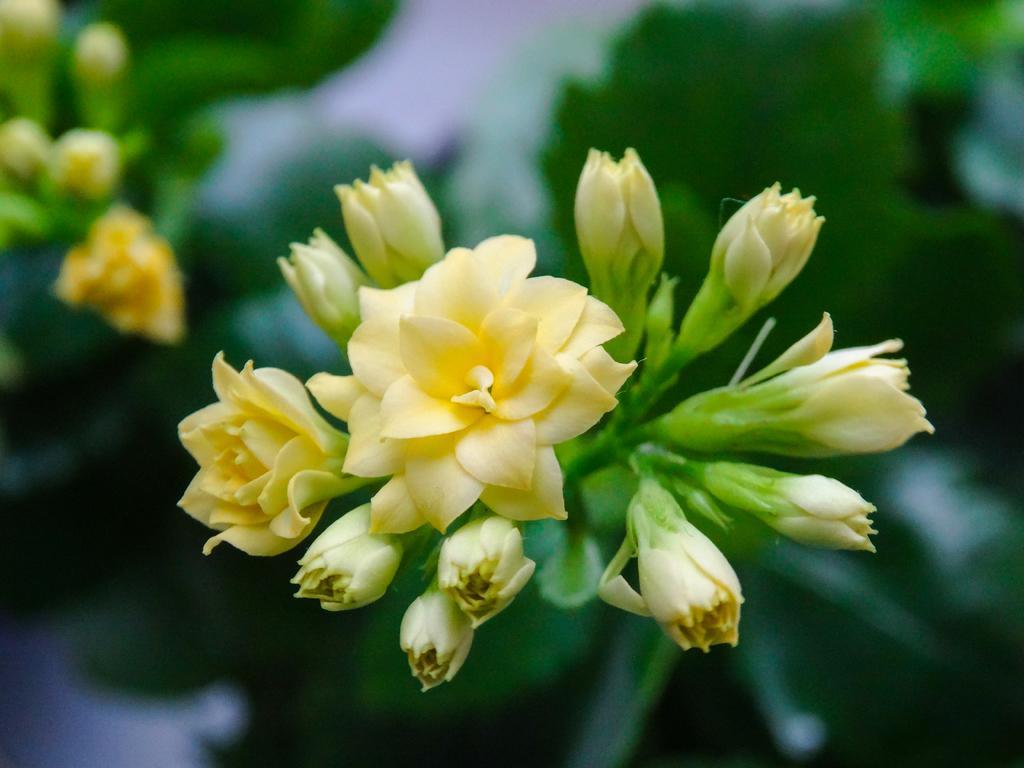Describe this image in one or two sentences. In this image we can see some yellow colored flowers and buds, the background is blurred. 